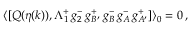Convert formula to latex. <formula><loc_0><loc_0><loc_500><loc_500>\langle [ Q ( \eta ( k ) ) , \Lambda _ { 1 } ^ { + } \, g _ { 2 } ^ { - } \, g _ { B ^ { \prime } } ^ { + } \, g _ { B } ^ { - } \, g _ { A } ^ { - } \, g _ { A ^ { \prime } } ^ { + } ] \rangle _ { 0 } = 0 \, ,</formula> 